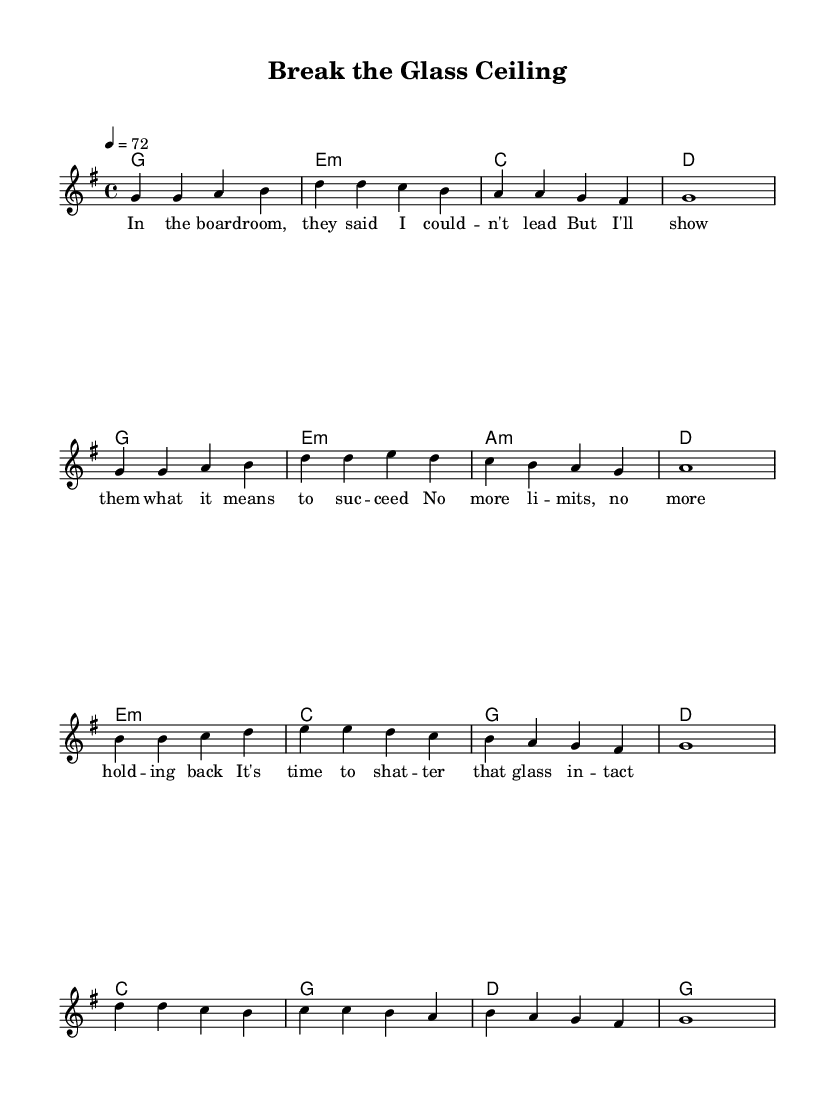What is the key signature of this music? The key signature is G major, indicated by one sharp (F#) at the beginning of the staff.
Answer: G major What is the time signature of this music? The time signature is 4/4, shown as a "4" over another "4" at the beginning of the measure.
Answer: 4/4 What is the tempo marking for this piece? The tempo marking is "4 = 72," which indicates a quarter note equals 72 beats per minute.
Answer: 72 How many measures are in the melody section? The melody section consists of 12 measures, counted by the number of vertical lines separating the measures.
Answer: 12 What chord is played during the first measure? The chord played in the first measure is G major, represented by the letter "g" above the staff.
Answer: G major What is the last lyric sung in this song? The last lyric sung is "that glass intact," which appears at the end of the text section.
Answer: that glass intact What is the style of this song? The style of this song is a pop ballad, characterized by its emotional depth and emphasis on themes of empowerment.
Answer: pop ballad 